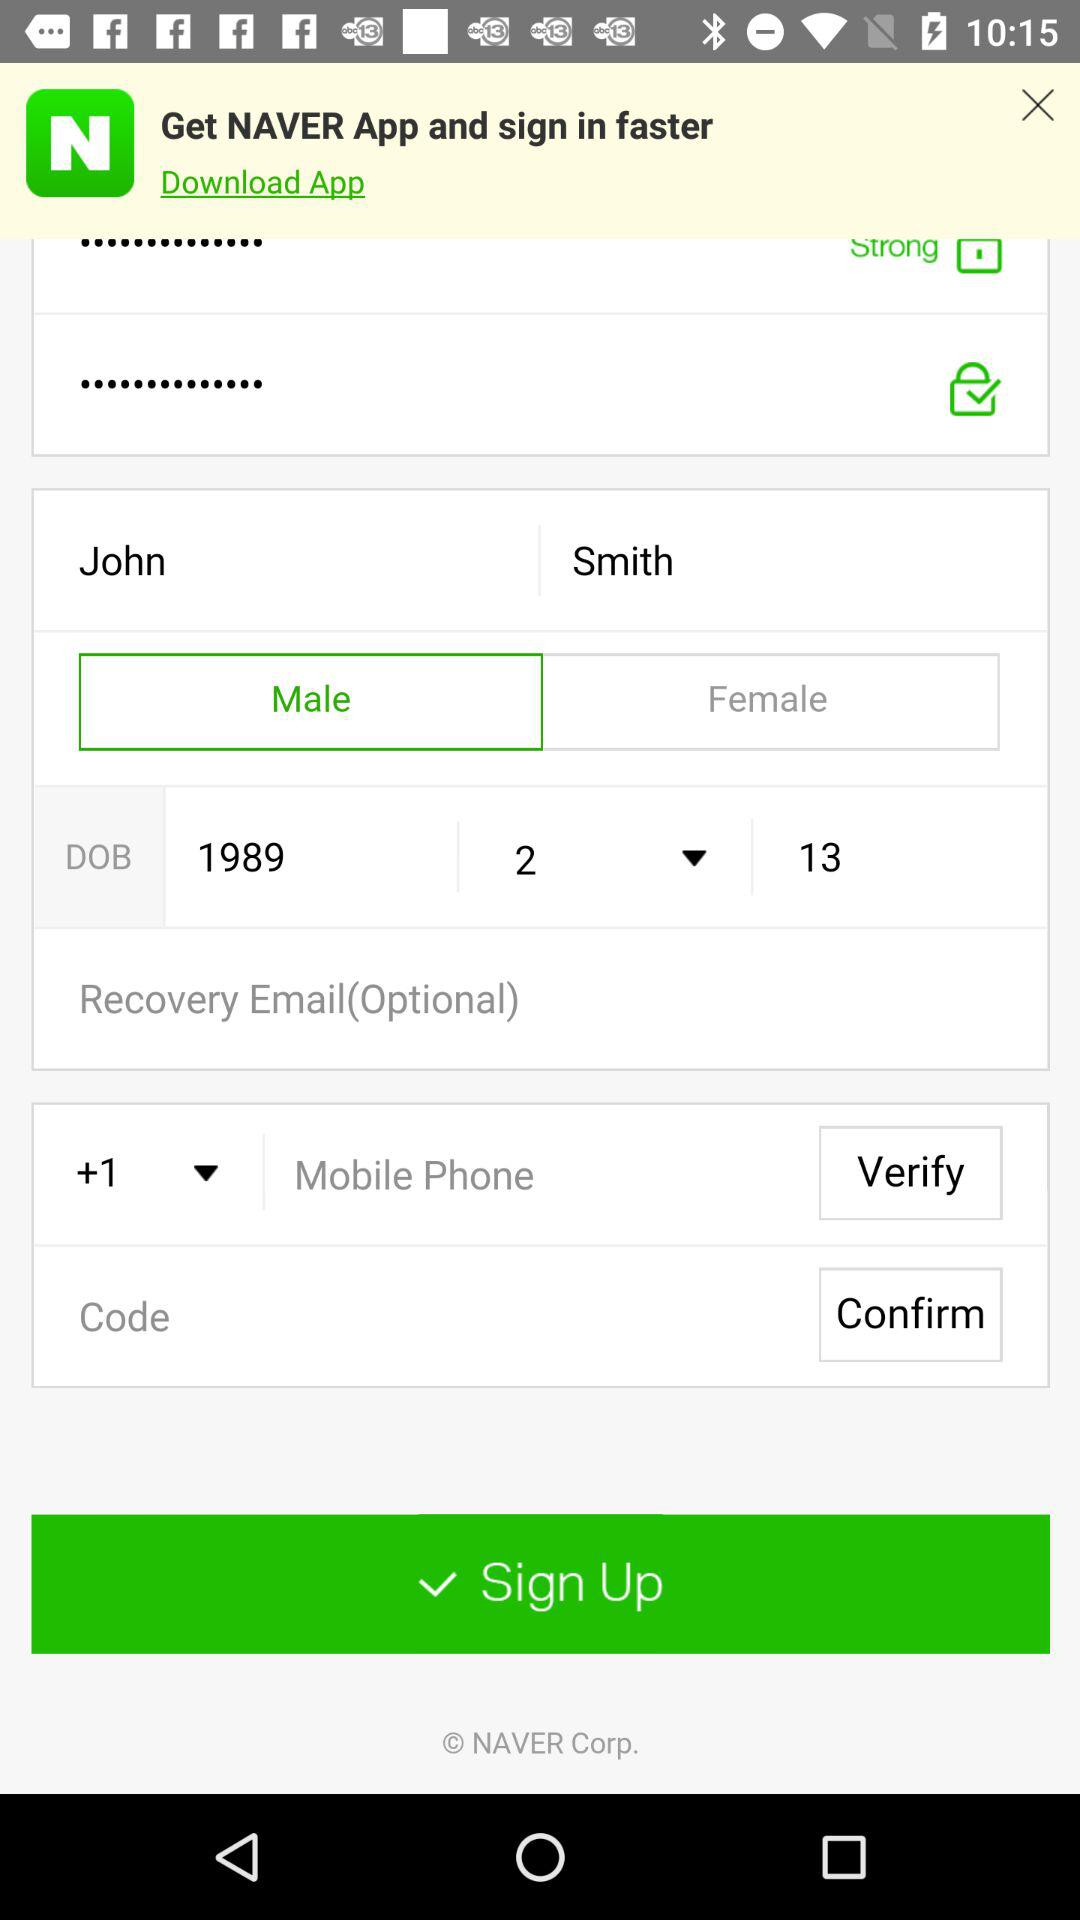What is the given profile name? The given profile name is John Smith. 